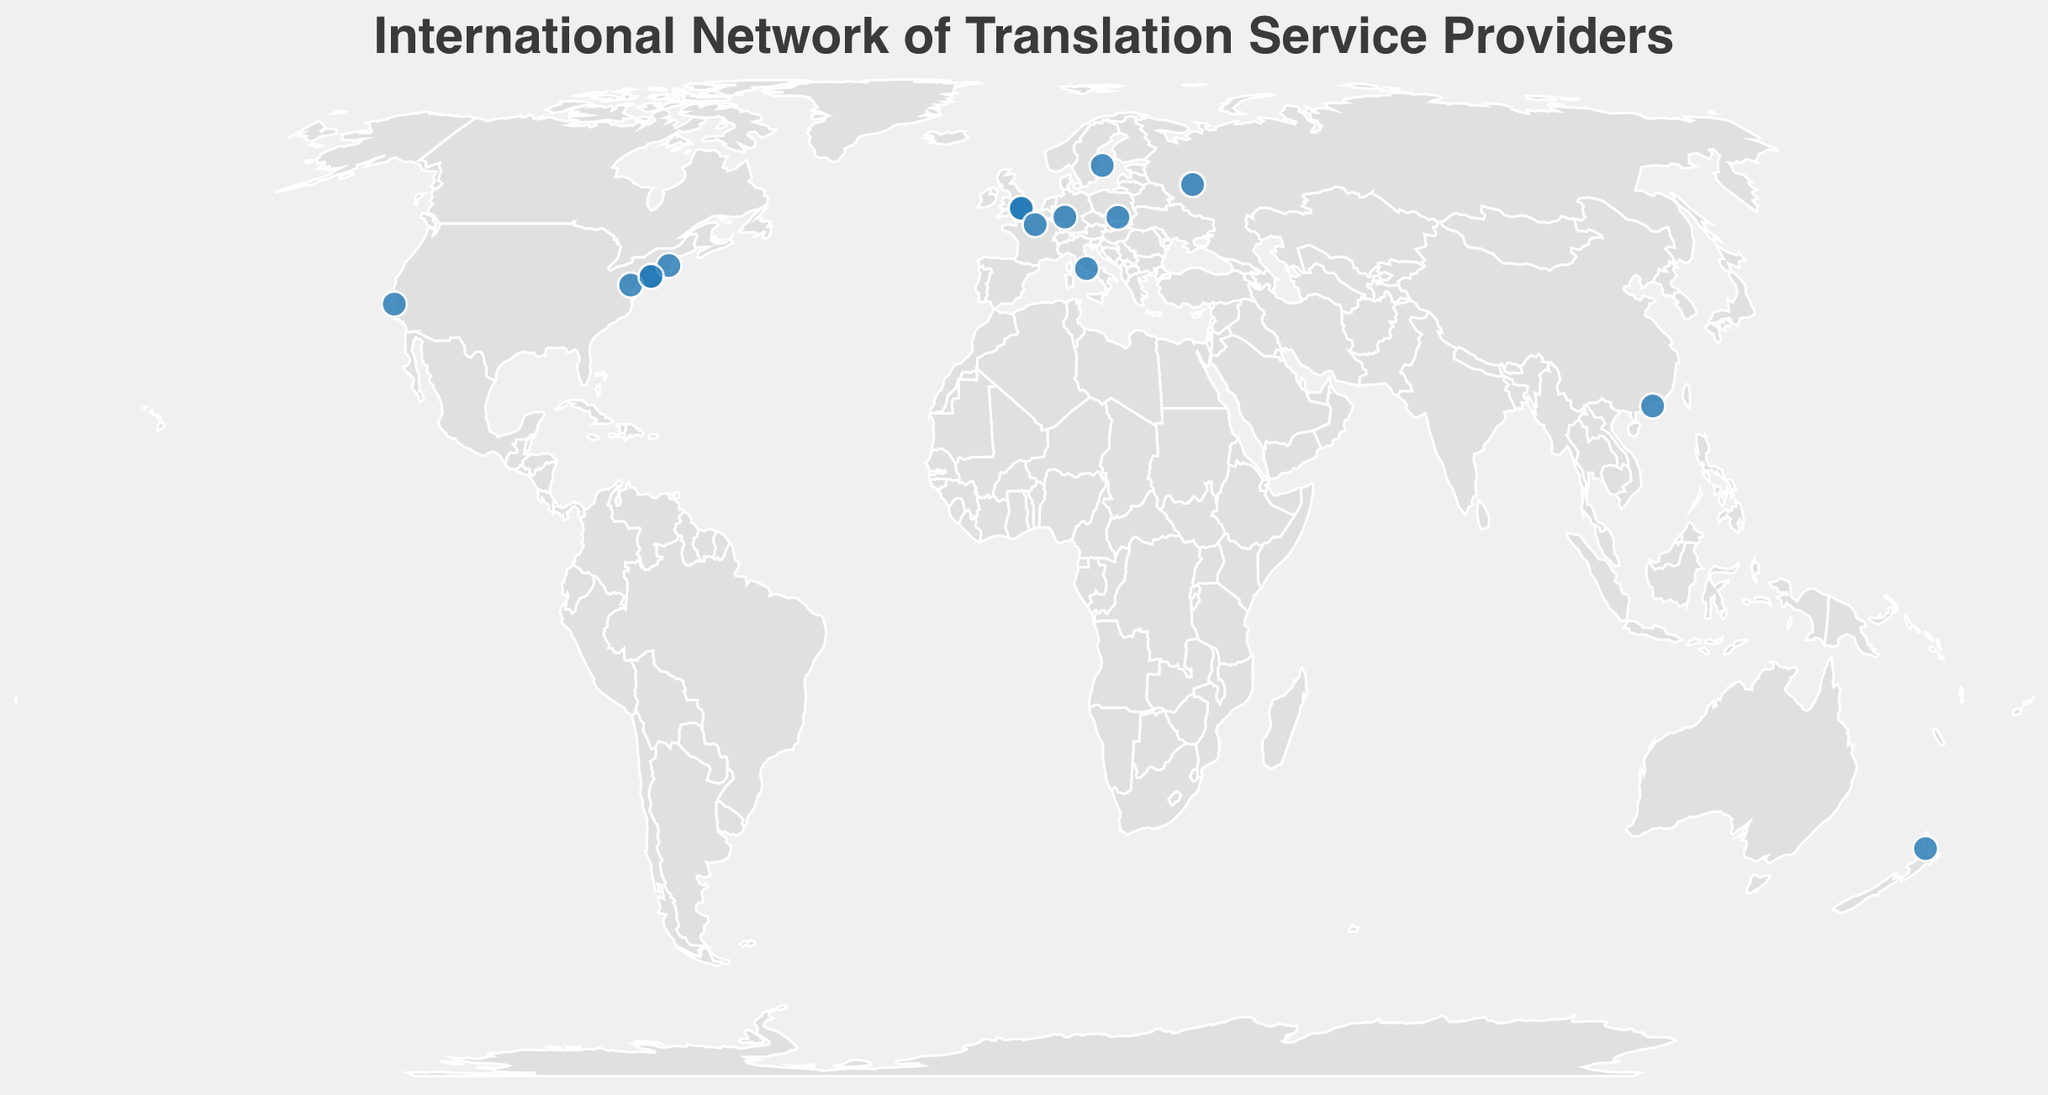What is the title of the plot? The title of the plot is prominently displayed at the top of the figure.
Answer: International Network of Translation Service Providers How many companies are represented in New York? The figure shows three circles in New York, indicating the presence of three companies.
Answer: Three Which company specializes in Patents & Life Sciences and where is it located? By hovering over the circles, you can see the tooltip that reveals the company's name, specialization, and location. The company specializing in Patents & Life Sciences is RWS Group, and it is located in Chalfont St Peter.
Answer: RWS Group, Chalfont St Peter Which companies are located in Europe and what are their specializations? There are circles on European locations, each representing a company. By hovering, you find that Translated (Rome) specializes in AI & Machine Translation, SDL (Maidenhead) in Marketing & Localization, Ubiqus (Paris) in Conference & Interpretation, RWS Group (Chalfont St Peter) in Patents & Life Sciences, and Argos Multilingual (Krakow) in Life Sciences & IT.
Answer: Translated - AI & Machine Translation, SDL - Marketing & Localization, Ubiqus - Conference & Interpretation, RWS Group - Patents & Life Sciences, Argos Multilingual - Life Sciences & IT Which specialization area has the most companies and how many? By counting the circles and their corresponding specializations, you note that Software Localization has two companies: TransPerfect (New York) and Acclaro (New York).
Answer: Software Localization, Two Compared to New York, how many fewer companies are based in Stockholm? New York has three companies, and Stockholm has one. The difference is calculated by subtracting one from three.
Answer: Two fewer Which company is furthest south and what is its specialization? The southernmost circle represents the company Straker Translations located in Auckland. This is determined by its latitude.
Answer: Straker Translations, E-commerce & Retail How does the specialization focus vary between the companies in Frankfurt and Paris? By comparing the tooltips for Frankfurt and Paris, you find that KERN AG in Frankfurt specializes in Industrial & Engineering while Ubiqus in Paris specializes in Conference & Interpretation.
Answer: Frankfurt - Industrial & Engineering, Paris - Conference & Interpretation Of the companies located in the United States, which one specializes in Healthcare & Government? The figure shows several companies in the United States, and by checking each tooltip, you identify LanguageLine Solutions in Monterey as specializing in Healthcare & Government.
Answer: LanguageLine Solutions Which region (North America or Europe) has more diverse specializations based on the companies present? By reviewing the specializations of companies in both regions, you find that Europe covers AI & Machine Translation, Marketing & Localization, Conference & Interpretation, Patents & Life Sciences, Life Sciences & IT, and Industrial & Engineering; whereas North America covers Legal & Financial, Technical & Software, Digital Content, Healthcare & Government, and Software Localization (compared to fewer unique categories). Therefore, Europe has more diverse specializations.
Answer: Europe 